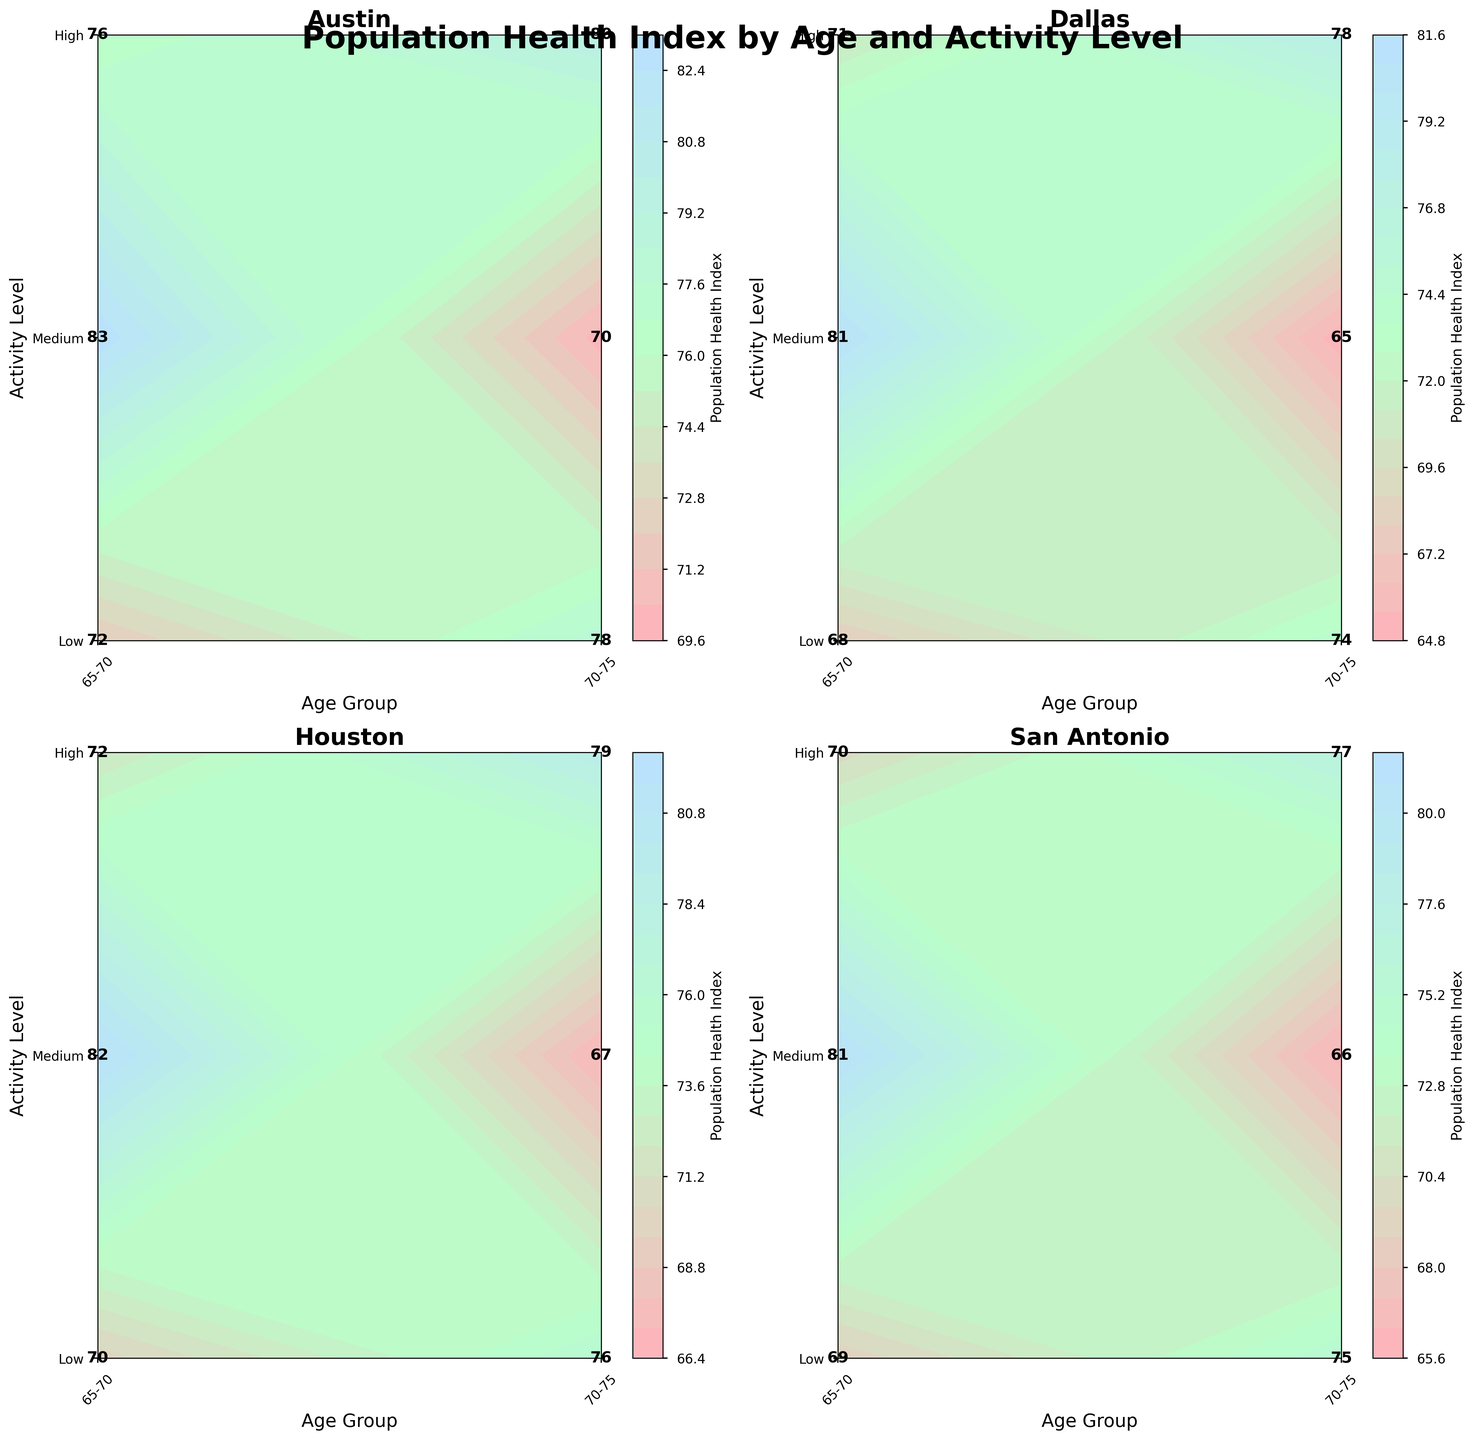What is the title of the figure? The title is usually displayed at the top of the figure in a larger and bold font. Here, it is stated explicitly in the plot generation instructions.
Answer: Population Health Index by Age and Activity Level Which community has the highest population health index for the age group 65-70 with high activity level? Look at the labels on each subplot, find the data point corresponding to 65-70 and High activity level, and compare the values. According to the data, Austin has the highest value of 83.
Answer: Austin What's the color code representing the highest population health index value in the contour plot? The highest health index values will correspond to the darkest or most intense color on the color bar.
Answer: Darker blue What is the population health index for the 70-75 age group with medium activity level in Houston? Locate Houston's subplot, find the contour label where age group is 70-75 and activity level is Medium, and read the corresponding value.
Answer: 72 Which community shows the lowest overall population health index across all age and activity levels? Compare the health index values across all plots and identify the community with the lowest values. Dallas has the value of 65 for the 70-75 age and low activity level, which is the lowest.
Answer: Dallas Is there a community where the health index for 65-70 age group with medium activity level is higher than that of the 65-70 age group with high activity level? Compare the values of Medium and High activity levels for the 65-70 age group across all communities. No community shows this, all High activity level values are higher than Medium.
Answer: No For the community of Dallas, what is the range of the population health index for different activity levels in the 70-75 age group? Range is calculated by finding the difference between the maximum and minimum values. For Dallas, the values are 78 (High) and 65 (Low). Range = 78 - 65 = 13.
Answer: 13 Which age group in San Antonio has a higher health index on average, 65-70 or 70-75? Calculate the average by summing the health index values for each activity level within each age group and then divide by the number of activity levels. For 65-70: (69+75+81)/3 = 75, for 70-75: (66+70+77)/3 ≈ 71.
Answer: 65-70 How does the health index change for Houston when moving from low to high activity level in the 65-70 age group? Find the health index value for Low, Medium, and High activity levels in the 65-70 age group in Houston and observe the trend. Values: 70 (Low), 76 (Medium), 82 (High). The health index increases as activity level increases.
Answer: Increases What is the average health index for the 70-75 age group with low activity level across all communities? Calculate by summing the health indices for 70-75 with Low activity level in each community and divide by the number of communities. (70+65+67+66)/4 = 67.
Answer: 67 